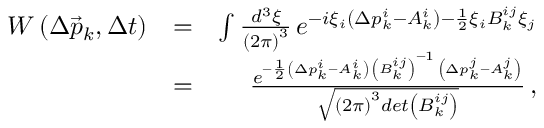Convert formula to latex. <formula><loc_0><loc_0><loc_500><loc_500>\begin{array} { r l r } { W \left ( \Delta \vec { p } _ { k } , \Delta t \right ) } & { = } & { \int \frac { d ^ { 3 } \xi } { \left ( 2 \pi \right ) ^ { 3 } } \, e ^ { - i \xi _ { i } \left ( \Delta p _ { k } ^ { i } - A _ { k } ^ { i } \right ) - \frac { 1 } { 2 } \xi _ { i } B _ { k } ^ { i j } \xi _ { j } } } \\ & { = } & { \frac { e ^ { - \frac { 1 } { 2 } \left ( \Delta p _ { k } ^ { i } - A _ { k } ^ { i } \right ) \, \left ( B _ { k } ^ { i j } \right ) ^ { - 1 } \, \left ( \Delta p _ { k } ^ { j } - A _ { k } ^ { j } \right ) } } { \sqrt { \left ( 2 \pi \right ) ^ { 3 } d e t \left ( B _ { k } ^ { i j } \right ) } } \, , } \end{array}</formula> 